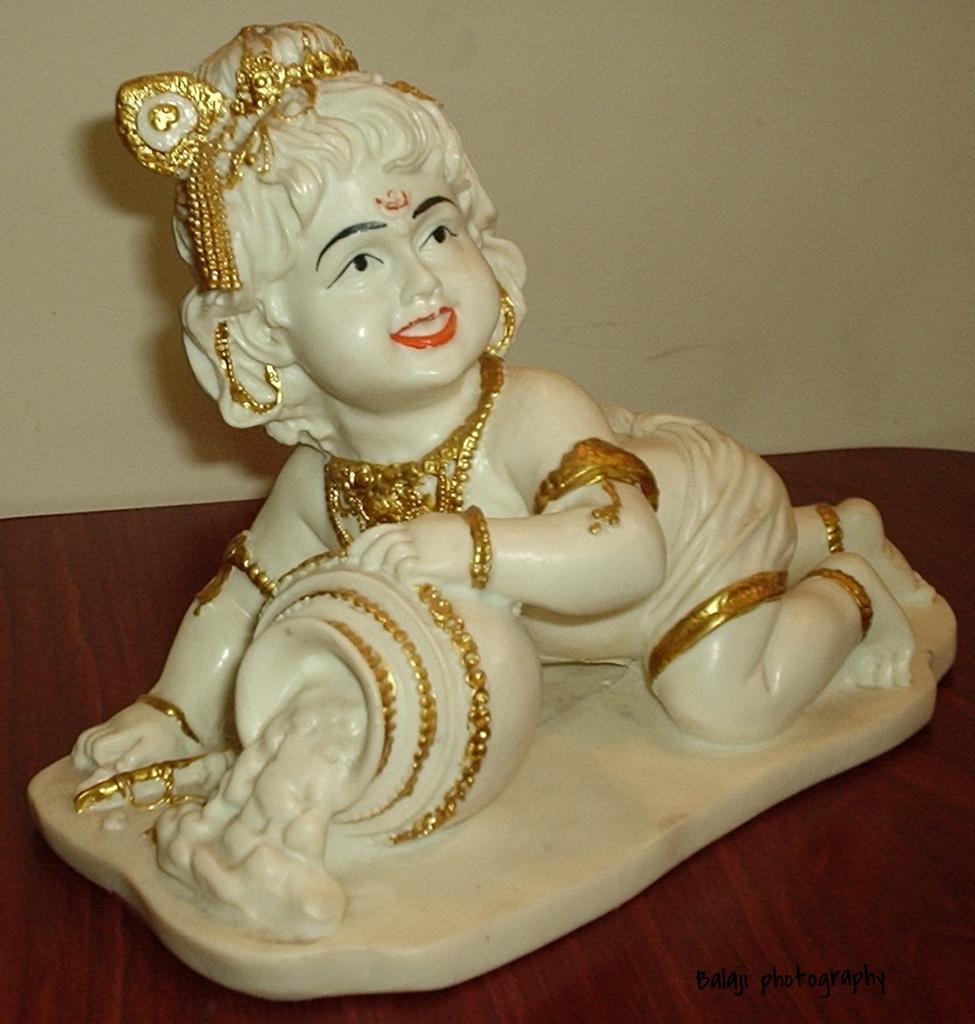Can you describe this image briefly? In this picture I can see the white idol statue which is kept on the table. In the back there is a wall. 